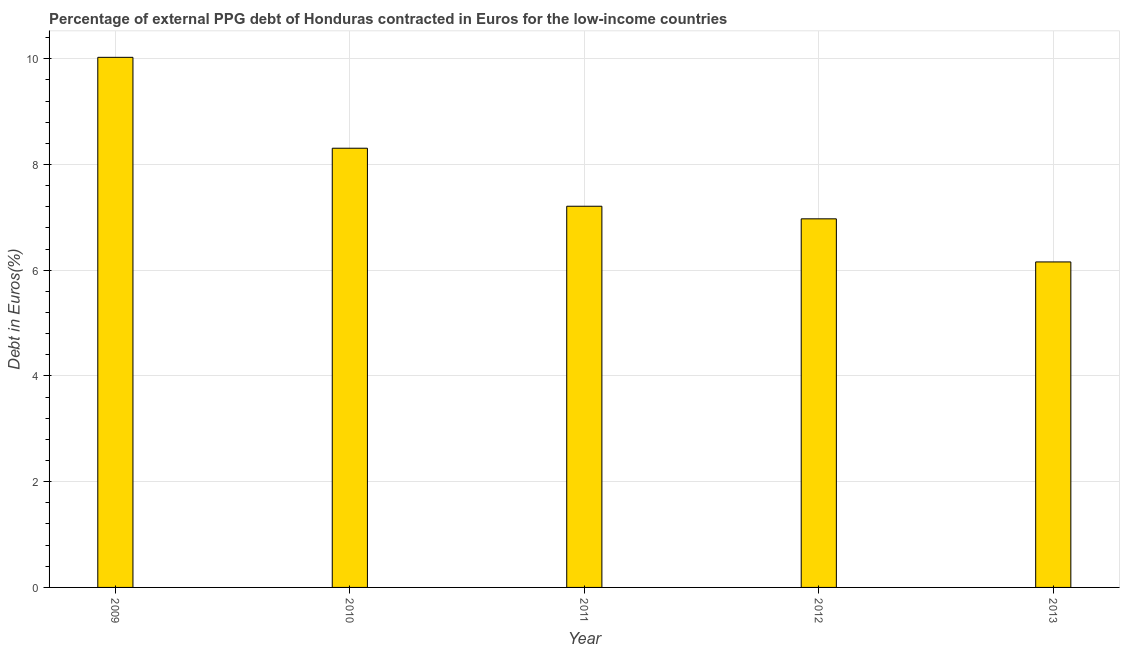What is the title of the graph?
Give a very brief answer. Percentage of external PPG debt of Honduras contracted in Euros for the low-income countries. What is the label or title of the Y-axis?
Offer a terse response. Debt in Euros(%). What is the currency composition of ppg debt in 2013?
Ensure brevity in your answer.  6.16. Across all years, what is the maximum currency composition of ppg debt?
Offer a terse response. 10.03. Across all years, what is the minimum currency composition of ppg debt?
Offer a very short reply. 6.16. In which year was the currency composition of ppg debt maximum?
Offer a terse response. 2009. What is the sum of the currency composition of ppg debt?
Your answer should be compact. 38.68. What is the difference between the currency composition of ppg debt in 2011 and 2013?
Make the answer very short. 1.05. What is the average currency composition of ppg debt per year?
Provide a succinct answer. 7.74. What is the median currency composition of ppg debt?
Give a very brief answer. 7.21. What is the ratio of the currency composition of ppg debt in 2009 to that in 2011?
Your answer should be very brief. 1.39. Is the difference between the currency composition of ppg debt in 2011 and 2013 greater than the difference between any two years?
Your answer should be compact. No. What is the difference between the highest and the second highest currency composition of ppg debt?
Give a very brief answer. 1.72. Is the sum of the currency composition of ppg debt in 2012 and 2013 greater than the maximum currency composition of ppg debt across all years?
Ensure brevity in your answer.  Yes. What is the difference between the highest and the lowest currency composition of ppg debt?
Give a very brief answer. 3.87. How many bars are there?
Make the answer very short. 5. What is the difference between two consecutive major ticks on the Y-axis?
Offer a very short reply. 2. Are the values on the major ticks of Y-axis written in scientific E-notation?
Ensure brevity in your answer.  No. What is the Debt in Euros(%) in 2009?
Offer a terse response. 10.03. What is the Debt in Euros(%) in 2010?
Your answer should be very brief. 8.31. What is the Debt in Euros(%) in 2011?
Your response must be concise. 7.21. What is the Debt in Euros(%) of 2012?
Give a very brief answer. 6.97. What is the Debt in Euros(%) of 2013?
Keep it short and to the point. 6.16. What is the difference between the Debt in Euros(%) in 2009 and 2010?
Provide a short and direct response. 1.72. What is the difference between the Debt in Euros(%) in 2009 and 2011?
Ensure brevity in your answer.  2.82. What is the difference between the Debt in Euros(%) in 2009 and 2012?
Your response must be concise. 3.06. What is the difference between the Debt in Euros(%) in 2009 and 2013?
Your answer should be very brief. 3.87. What is the difference between the Debt in Euros(%) in 2010 and 2011?
Keep it short and to the point. 1.1. What is the difference between the Debt in Euros(%) in 2010 and 2012?
Offer a terse response. 1.34. What is the difference between the Debt in Euros(%) in 2010 and 2013?
Your response must be concise. 2.15. What is the difference between the Debt in Euros(%) in 2011 and 2012?
Your response must be concise. 0.24. What is the difference between the Debt in Euros(%) in 2011 and 2013?
Your answer should be very brief. 1.05. What is the difference between the Debt in Euros(%) in 2012 and 2013?
Make the answer very short. 0.82. What is the ratio of the Debt in Euros(%) in 2009 to that in 2010?
Offer a terse response. 1.21. What is the ratio of the Debt in Euros(%) in 2009 to that in 2011?
Your response must be concise. 1.39. What is the ratio of the Debt in Euros(%) in 2009 to that in 2012?
Keep it short and to the point. 1.44. What is the ratio of the Debt in Euros(%) in 2009 to that in 2013?
Make the answer very short. 1.63. What is the ratio of the Debt in Euros(%) in 2010 to that in 2011?
Keep it short and to the point. 1.15. What is the ratio of the Debt in Euros(%) in 2010 to that in 2012?
Offer a terse response. 1.19. What is the ratio of the Debt in Euros(%) in 2010 to that in 2013?
Offer a very short reply. 1.35. What is the ratio of the Debt in Euros(%) in 2011 to that in 2012?
Your response must be concise. 1.03. What is the ratio of the Debt in Euros(%) in 2011 to that in 2013?
Keep it short and to the point. 1.17. What is the ratio of the Debt in Euros(%) in 2012 to that in 2013?
Your response must be concise. 1.13. 